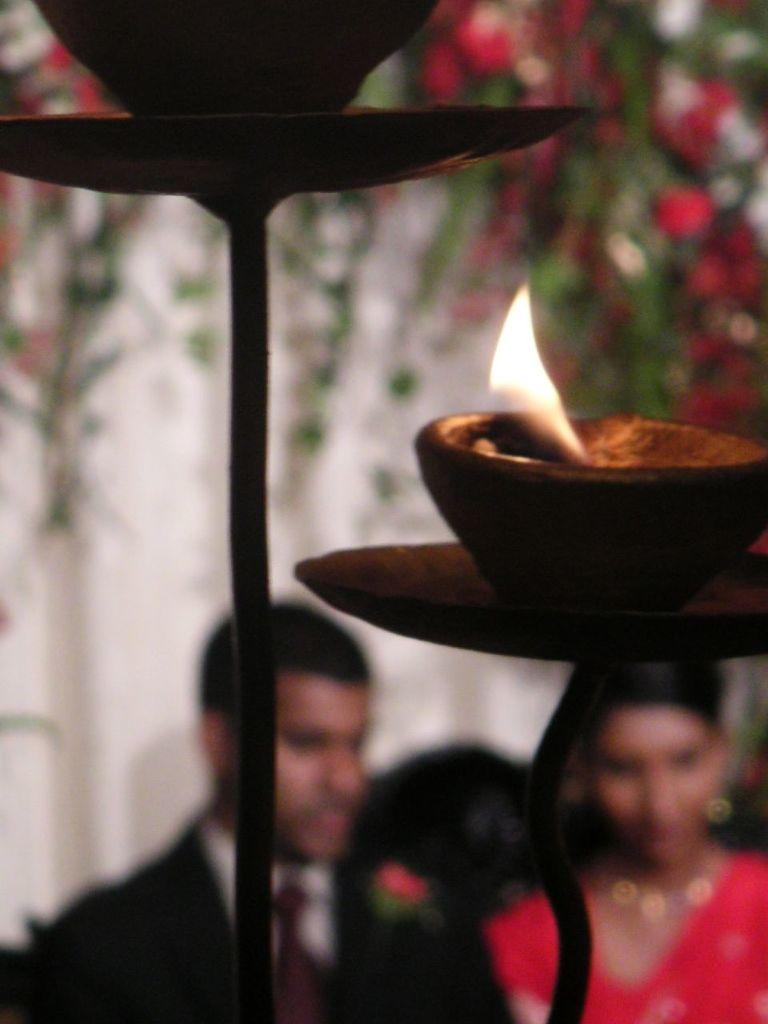What is the main subject of the image? The main subject of the image is days on a stand. Can you describe the people visible in the background? There are two people visible in the background. What other elements can be seen in the image? There are colorful flowers in the image. What type of trousers is the creator wearing in the image? There is no creator present in the image, and therefore no trousers can be observed. Can you describe the face of the person holding the stand with days? The image does not show the person holding the stand with days, so their face cannot be described. 